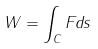Convert formula to latex. <formula><loc_0><loc_0><loc_500><loc_500>W = \int _ { C } F d s</formula> 